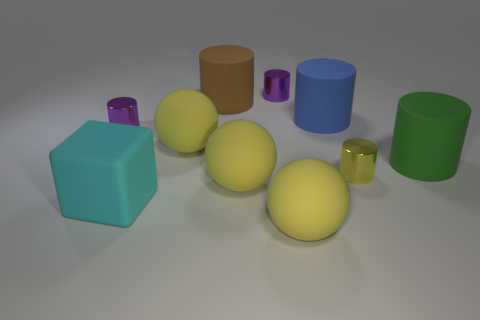Subtract all large blue rubber cylinders. How many cylinders are left? 5 Subtract all yellow cylinders. How many cylinders are left? 5 Subtract all spheres. How many objects are left? 7 Subtract all red spheres. Subtract all gray cylinders. How many spheres are left? 3 Subtract all gray balls. How many brown cylinders are left? 1 Subtract all large brown matte objects. Subtract all tiny purple things. How many objects are left? 7 Add 2 large cyan cubes. How many large cyan cubes are left? 3 Add 8 small purple cylinders. How many small purple cylinders exist? 10 Subtract 1 green cylinders. How many objects are left? 9 Subtract 3 spheres. How many spheres are left? 0 